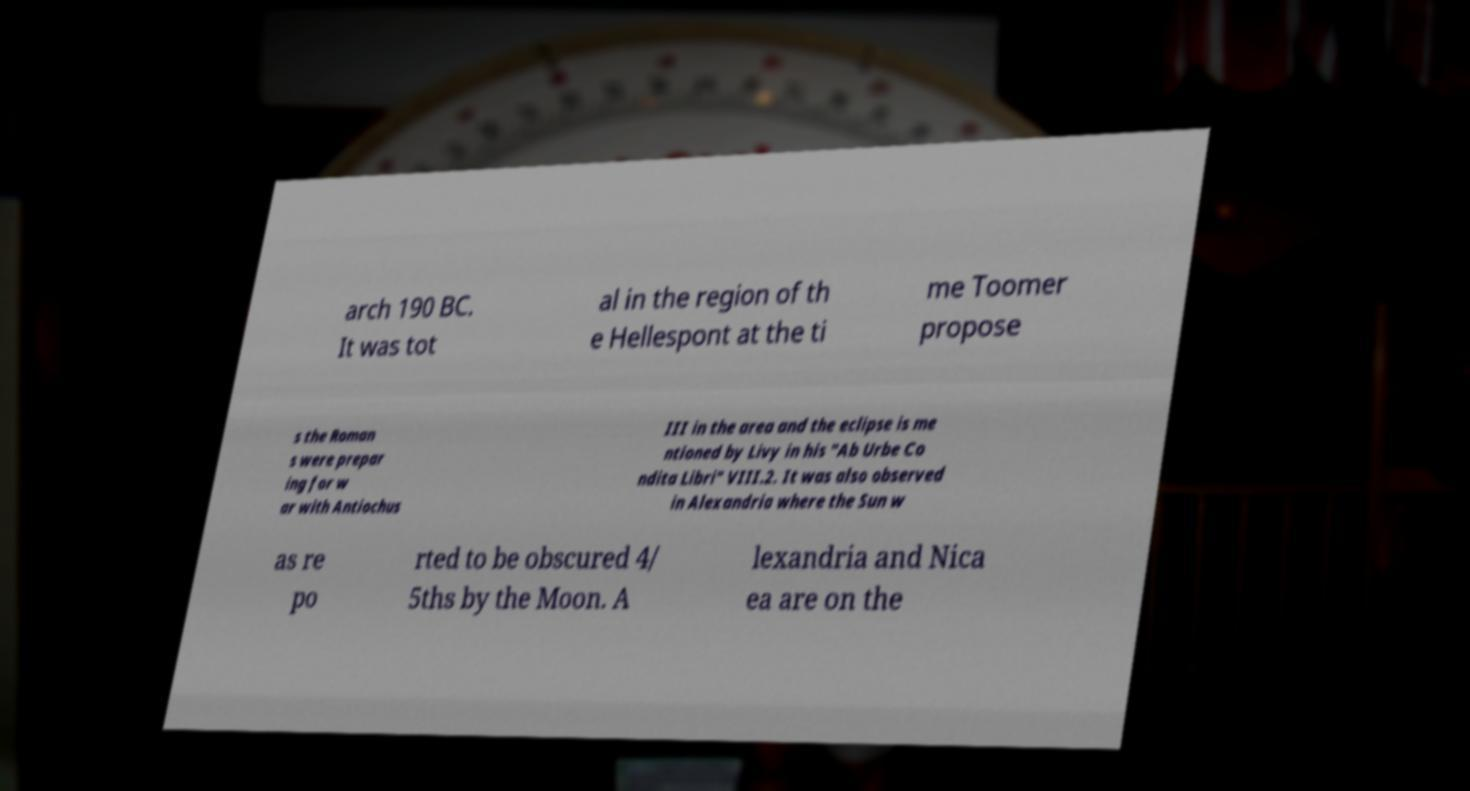Could you assist in decoding the text presented in this image and type it out clearly? arch 190 BC. It was tot al in the region of th e Hellespont at the ti me Toomer propose s the Roman s were prepar ing for w ar with Antiochus III in the area and the eclipse is me ntioned by Livy in his "Ab Urbe Co ndita Libri" VIII.2. It was also observed in Alexandria where the Sun w as re po rted to be obscured 4/ 5ths by the Moon. A lexandria and Nica ea are on the 